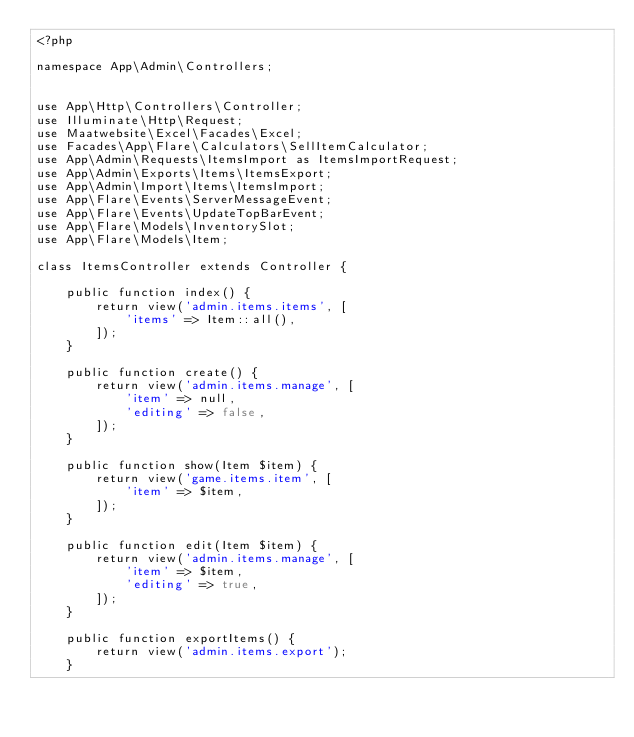<code> <loc_0><loc_0><loc_500><loc_500><_PHP_><?php

namespace App\Admin\Controllers;


use App\Http\Controllers\Controller;
use Illuminate\Http\Request;
use Maatwebsite\Excel\Facades\Excel;
use Facades\App\Flare\Calculators\SellItemCalculator;
use App\Admin\Requests\ItemsImport as ItemsImportRequest;
use App\Admin\Exports\Items\ItemsExport;
use App\Admin\Import\Items\ItemsImport;
use App\Flare\Events\ServerMessageEvent;
use App\Flare\Events\UpdateTopBarEvent;
use App\Flare\Models\InventorySlot;
use App\Flare\Models\Item;

class ItemsController extends Controller {

    public function index() {
        return view('admin.items.items', [
            'items' => Item::all(),
        ]);
    }

    public function create() {
        return view('admin.items.manage', [
            'item' => null,
            'editing' => false,
        ]);
    }

    public function show(Item $item) {
        return view('game.items.item', [
            'item' => $item,
        ]);
    }

    public function edit(Item $item) {
        return view('admin.items.manage', [
            'item' => $item,
            'editing' => true,
        ]);
    }

    public function exportItems() {
        return view('admin.items.export');
    }
</code> 